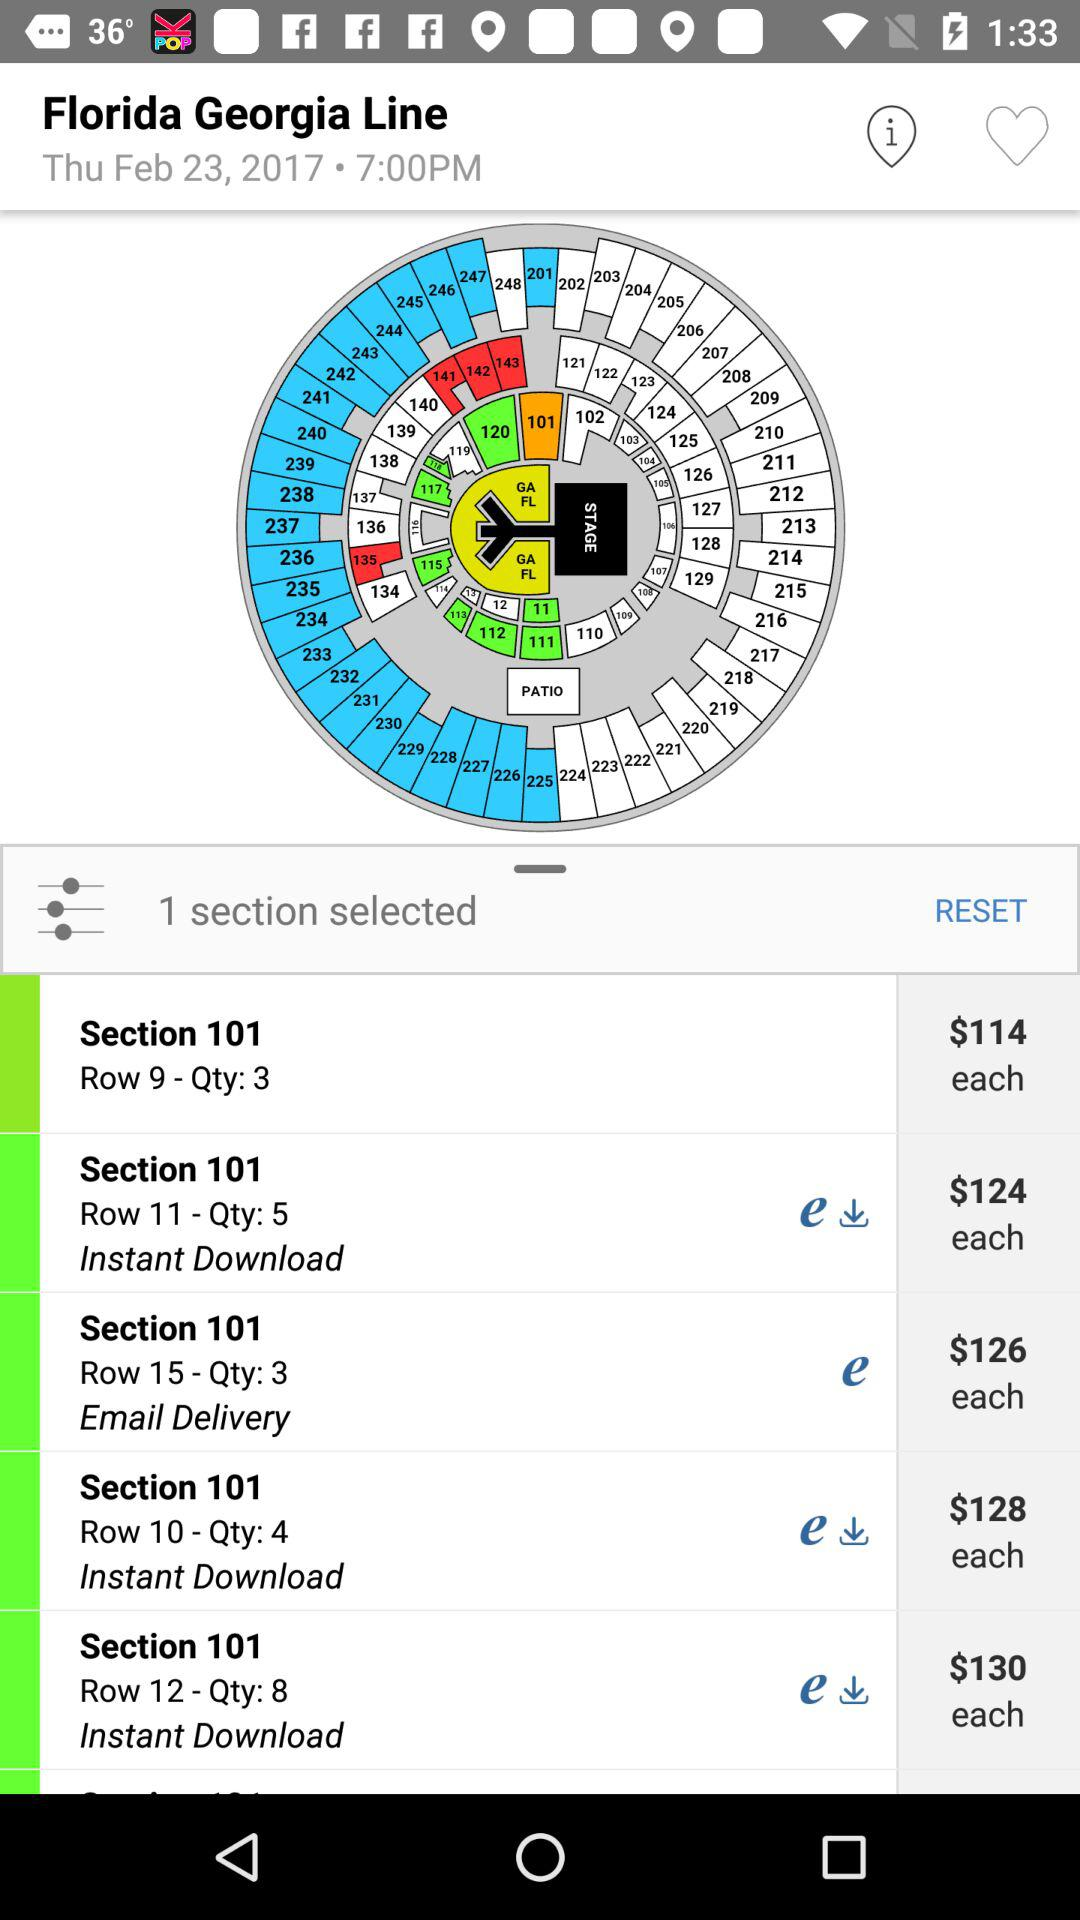Which section has email delivery? The section 101 has email delivery. 